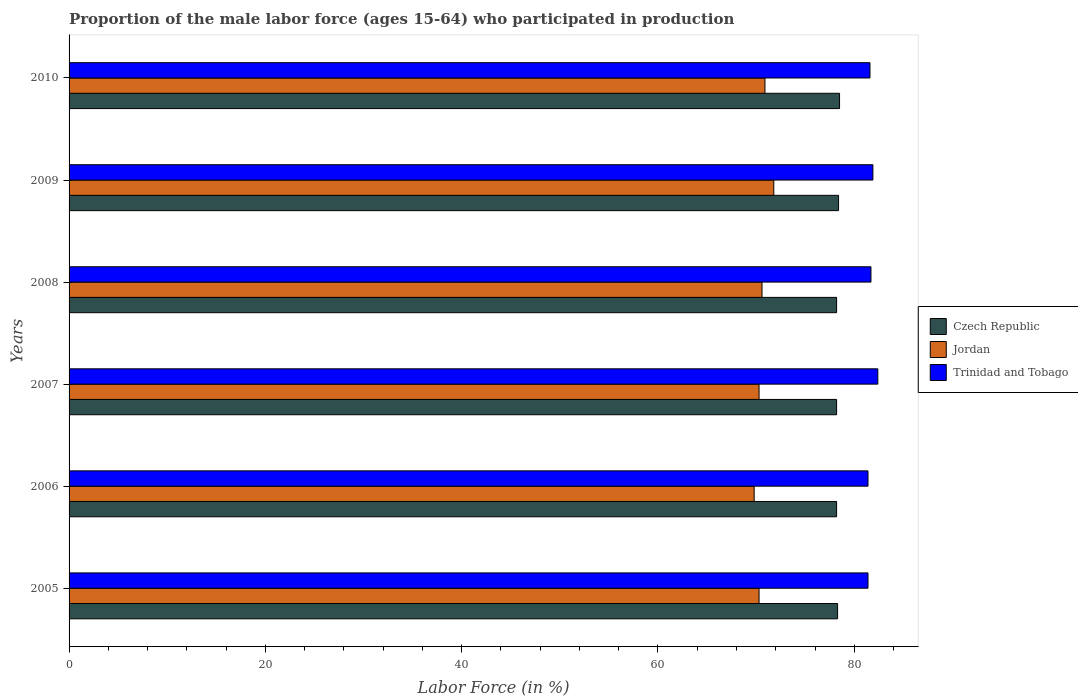How many groups of bars are there?
Ensure brevity in your answer.  6. How many bars are there on the 6th tick from the bottom?
Offer a terse response. 3. In how many cases, is the number of bars for a given year not equal to the number of legend labels?
Offer a very short reply. 0. What is the proportion of the male labor force who participated in production in Jordan in 2008?
Your answer should be very brief. 70.6. Across all years, what is the maximum proportion of the male labor force who participated in production in Trinidad and Tobago?
Your answer should be compact. 82.4. Across all years, what is the minimum proportion of the male labor force who participated in production in Czech Republic?
Keep it short and to the point. 78.2. In which year was the proportion of the male labor force who participated in production in Trinidad and Tobago minimum?
Offer a very short reply. 2005. What is the total proportion of the male labor force who participated in production in Trinidad and Tobago in the graph?
Provide a short and direct response. 490.4. What is the difference between the proportion of the male labor force who participated in production in Czech Republic in 2005 and that in 2010?
Your response must be concise. -0.2. What is the difference between the proportion of the male labor force who participated in production in Trinidad and Tobago in 2006 and the proportion of the male labor force who participated in production in Czech Republic in 2009?
Give a very brief answer. 3. What is the average proportion of the male labor force who participated in production in Trinidad and Tobago per year?
Provide a succinct answer. 81.73. In the year 2010, what is the difference between the proportion of the male labor force who participated in production in Trinidad and Tobago and proportion of the male labor force who participated in production in Czech Republic?
Make the answer very short. 3.1. In how many years, is the proportion of the male labor force who participated in production in Jordan greater than 68 %?
Your response must be concise. 6. What is the ratio of the proportion of the male labor force who participated in production in Jordan in 2005 to that in 2010?
Keep it short and to the point. 0.99. Is the proportion of the male labor force who participated in production in Trinidad and Tobago in 2008 less than that in 2009?
Offer a terse response. Yes. What is the difference between the highest and the second highest proportion of the male labor force who participated in production in Jordan?
Ensure brevity in your answer.  0.9. In how many years, is the proportion of the male labor force who participated in production in Jordan greater than the average proportion of the male labor force who participated in production in Jordan taken over all years?
Your answer should be very brief. 2. Is the sum of the proportion of the male labor force who participated in production in Czech Republic in 2009 and 2010 greater than the maximum proportion of the male labor force who participated in production in Trinidad and Tobago across all years?
Provide a succinct answer. Yes. What does the 3rd bar from the top in 2008 represents?
Offer a very short reply. Czech Republic. What does the 2nd bar from the bottom in 2006 represents?
Your answer should be compact. Jordan. How many years are there in the graph?
Ensure brevity in your answer.  6. Are the values on the major ticks of X-axis written in scientific E-notation?
Ensure brevity in your answer.  No. Does the graph contain any zero values?
Your answer should be very brief. No. Does the graph contain grids?
Your answer should be very brief. No. How many legend labels are there?
Ensure brevity in your answer.  3. What is the title of the graph?
Keep it short and to the point. Proportion of the male labor force (ages 15-64) who participated in production. What is the Labor Force (in %) of Czech Republic in 2005?
Your response must be concise. 78.3. What is the Labor Force (in %) in Jordan in 2005?
Keep it short and to the point. 70.3. What is the Labor Force (in %) in Trinidad and Tobago in 2005?
Make the answer very short. 81.4. What is the Labor Force (in %) in Czech Republic in 2006?
Offer a very short reply. 78.2. What is the Labor Force (in %) of Jordan in 2006?
Give a very brief answer. 69.8. What is the Labor Force (in %) in Trinidad and Tobago in 2006?
Give a very brief answer. 81.4. What is the Labor Force (in %) of Czech Republic in 2007?
Provide a short and direct response. 78.2. What is the Labor Force (in %) of Jordan in 2007?
Keep it short and to the point. 70.3. What is the Labor Force (in %) of Trinidad and Tobago in 2007?
Offer a terse response. 82.4. What is the Labor Force (in %) in Czech Republic in 2008?
Make the answer very short. 78.2. What is the Labor Force (in %) in Jordan in 2008?
Offer a very short reply. 70.6. What is the Labor Force (in %) in Trinidad and Tobago in 2008?
Give a very brief answer. 81.7. What is the Labor Force (in %) in Czech Republic in 2009?
Your answer should be very brief. 78.4. What is the Labor Force (in %) of Jordan in 2009?
Give a very brief answer. 71.8. What is the Labor Force (in %) in Trinidad and Tobago in 2009?
Keep it short and to the point. 81.9. What is the Labor Force (in %) in Czech Republic in 2010?
Your answer should be compact. 78.5. What is the Labor Force (in %) in Jordan in 2010?
Make the answer very short. 70.9. What is the Labor Force (in %) in Trinidad and Tobago in 2010?
Your answer should be very brief. 81.6. Across all years, what is the maximum Labor Force (in %) of Czech Republic?
Offer a very short reply. 78.5. Across all years, what is the maximum Labor Force (in %) of Jordan?
Your answer should be very brief. 71.8. Across all years, what is the maximum Labor Force (in %) in Trinidad and Tobago?
Your answer should be very brief. 82.4. Across all years, what is the minimum Labor Force (in %) in Czech Republic?
Your response must be concise. 78.2. Across all years, what is the minimum Labor Force (in %) of Jordan?
Make the answer very short. 69.8. Across all years, what is the minimum Labor Force (in %) in Trinidad and Tobago?
Keep it short and to the point. 81.4. What is the total Labor Force (in %) of Czech Republic in the graph?
Keep it short and to the point. 469.8. What is the total Labor Force (in %) of Jordan in the graph?
Provide a succinct answer. 423.7. What is the total Labor Force (in %) in Trinidad and Tobago in the graph?
Offer a very short reply. 490.4. What is the difference between the Labor Force (in %) in Czech Republic in 2005 and that in 2006?
Offer a very short reply. 0.1. What is the difference between the Labor Force (in %) of Jordan in 2005 and that in 2007?
Provide a succinct answer. 0. What is the difference between the Labor Force (in %) in Trinidad and Tobago in 2005 and that in 2007?
Provide a short and direct response. -1. What is the difference between the Labor Force (in %) in Czech Republic in 2005 and that in 2008?
Keep it short and to the point. 0.1. What is the difference between the Labor Force (in %) of Czech Republic in 2005 and that in 2009?
Offer a terse response. -0.1. What is the difference between the Labor Force (in %) in Jordan in 2005 and that in 2009?
Provide a succinct answer. -1.5. What is the difference between the Labor Force (in %) in Trinidad and Tobago in 2005 and that in 2009?
Provide a succinct answer. -0.5. What is the difference between the Labor Force (in %) in Czech Republic in 2005 and that in 2010?
Your response must be concise. -0.2. What is the difference between the Labor Force (in %) in Czech Republic in 2006 and that in 2007?
Provide a short and direct response. 0. What is the difference between the Labor Force (in %) of Jordan in 2006 and that in 2008?
Keep it short and to the point. -0.8. What is the difference between the Labor Force (in %) of Jordan in 2006 and that in 2009?
Provide a short and direct response. -2. What is the difference between the Labor Force (in %) in Trinidad and Tobago in 2006 and that in 2009?
Make the answer very short. -0.5. What is the difference between the Labor Force (in %) of Czech Republic in 2006 and that in 2010?
Provide a succinct answer. -0.3. What is the difference between the Labor Force (in %) in Jordan in 2006 and that in 2010?
Your answer should be compact. -1.1. What is the difference between the Labor Force (in %) of Trinidad and Tobago in 2006 and that in 2010?
Offer a terse response. -0.2. What is the difference between the Labor Force (in %) in Jordan in 2007 and that in 2008?
Ensure brevity in your answer.  -0.3. What is the difference between the Labor Force (in %) in Trinidad and Tobago in 2007 and that in 2009?
Offer a terse response. 0.5. What is the difference between the Labor Force (in %) in Czech Republic in 2009 and that in 2010?
Your response must be concise. -0.1. What is the difference between the Labor Force (in %) of Jordan in 2009 and that in 2010?
Make the answer very short. 0.9. What is the difference between the Labor Force (in %) in Trinidad and Tobago in 2009 and that in 2010?
Make the answer very short. 0.3. What is the difference between the Labor Force (in %) of Czech Republic in 2005 and the Labor Force (in %) of Jordan in 2006?
Make the answer very short. 8.5. What is the difference between the Labor Force (in %) in Czech Republic in 2005 and the Labor Force (in %) in Trinidad and Tobago in 2006?
Make the answer very short. -3.1. What is the difference between the Labor Force (in %) of Jordan in 2005 and the Labor Force (in %) of Trinidad and Tobago in 2006?
Offer a very short reply. -11.1. What is the difference between the Labor Force (in %) of Jordan in 2005 and the Labor Force (in %) of Trinidad and Tobago in 2007?
Your answer should be compact. -12.1. What is the difference between the Labor Force (in %) in Czech Republic in 2005 and the Labor Force (in %) in Jordan in 2008?
Ensure brevity in your answer.  7.7. What is the difference between the Labor Force (in %) in Czech Republic in 2005 and the Labor Force (in %) in Jordan in 2009?
Keep it short and to the point. 6.5. What is the difference between the Labor Force (in %) in Czech Republic in 2006 and the Labor Force (in %) in Jordan in 2007?
Offer a very short reply. 7.9. What is the difference between the Labor Force (in %) in Czech Republic in 2006 and the Labor Force (in %) in Jordan in 2008?
Offer a terse response. 7.6. What is the difference between the Labor Force (in %) of Jordan in 2006 and the Labor Force (in %) of Trinidad and Tobago in 2008?
Ensure brevity in your answer.  -11.9. What is the difference between the Labor Force (in %) in Czech Republic in 2006 and the Labor Force (in %) in Jordan in 2009?
Provide a succinct answer. 6.4. What is the difference between the Labor Force (in %) of Czech Republic in 2006 and the Labor Force (in %) of Trinidad and Tobago in 2009?
Your answer should be compact. -3.7. What is the difference between the Labor Force (in %) of Jordan in 2006 and the Labor Force (in %) of Trinidad and Tobago in 2009?
Your response must be concise. -12.1. What is the difference between the Labor Force (in %) of Czech Republic in 2006 and the Labor Force (in %) of Jordan in 2010?
Offer a very short reply. 7.3. What is the difference between the Labor Force (in %) in Czech Republic in 2006 and the Labor Force (in %) in Trinidad and Tobago in 2010?
Your answer should be compact. -3.4. What is the difference between the Labor Force (in %) of Jordan in 2006 and the Labor Force (in %) of Trinidad and Tobago in 2010?
Your answer should be very brief. -11.8. What is the difference between the Labor Force (in %) in Czech Republic in 2007 and the Labor Force (in %) in Jordan in 2008?
Make the answer very short. 7.6. What is the difference between the Labor Force (in %) in Czech Republic in 2007 and the Labor Force (in %) in Trinidad and Tobago in 2008?
Your answer should be compact. -3.5. What is the difference between the Labor Force (in %) of Jordan in 2007 and the Labor Force (in %) of Trinidad and Tobago in 2008?
Keep it short and to the point. -11.4. What is the difference between the Labor Force (in %) in Czech Republic in 2007 and the Labor Force (in %) in Jordan in 2010?
Your response must be concise. 7.3. What is the difference between the Labor Force (in %) of Jordan in 2007 and the Labor Force (in %) of Trinidad and Tobago in 2010?
Provide a short and direct response. -11.3. What is the difference between the Labor Force (in %) of Czech Republic in 2008 and the Labor Force (in %) of Jordan in 2010?
Keep it short and to the point. 7.3. What is the difference between the Labor Force (in %) of Czech Republic in 2008 and the Labor Force (in %) of Trinidad and Tobago in 2010?
Your response must be concise. -3.4. What is the difference between the Labor Force (in %) of Jordan in 2009 and the Labor Force (in %) of Trinidad and Tobago in 2010?
Make the answer very short. -9.8. What is the average Labor Force (in %) in Czech Republic per year?
Provide a short and direct response. 78.3. What is the average Labor Force (in %) of Jordan per year?
Make the answer very short. 70.62. What is the average Labor Force (in %) in Trinidad and Tobago per year?
Offer a very short reply. 81.73. In the year 2005, what is the difference between the Labor Force (in %) in Czech Republic and Labor Force (in %) in Jordan?
Keep it short and to the point. 8. In the year 2005, what is the difference between the Labor Force (in %) in Czech Republic and Labor Force (in %) in Trinidad and Tobago?
Provide a succinct answer. -3.1. In the year 2006, what is the difference between the Labor Force (in %) in Jordan and Labor Force (in %) in Trinidad and Tobago?
Give a very brief answer. -11.6. In the year 2007, what is the difference between the Labor Force (in %) in Czech Republic and Labor Force (in %) in Jordan?
Provide a succinct answer. 7.9. In the year 2007, what is the difference between the Labor Force (in %) in Czech Republic and Labor Force (in %) in Trinidad and Tobago?
Provide a succinct answer. -4.2. In the year 2008, what is the difference between the Labor Force (in %) in Czech Republic and Labor Force (in %) in Trinidad and Tobago?
Your response must be concise. -3.5. In the year 2009, what is the difference between the Labor Force (in %) in Jordan and Labor Force (in %) in Trinidad and Tobago?
Provide a short and direct response. -10.1. What is the ratio of the Labor Force (in %) in Jordan in 2005 to that in 2006?
Your response must be concise. 1.01. What is the ratio of the Labor Force (in %) of Trinidad and Tobago in 2005 to that in 2006?
Your response must be concise. 1. What is the ratio of the Labor Force (in %) of Trinidad and Tobago in 2005 to that in 2007?
Provide a short and direct response. 0.99. What is the ratio of the Labor Force (in %) of Jordan in 2005 to that in 2008?
Offer a terse response. 1. What is the ratio of the Labor Force (in %) of Jordan in 2005 to that in 2009?
Your answer should be compact. 0.98. What is the ratio of the Labor Force (in %) in Czech Republic in 2005 to that in 2010?
Keep it short and to the point. 1. What is the ratio of the Labor Force (in %) of Trinidad and Tobago in 2005 to that in 2010?
Provide a succinct answer. 1. What is the ratio of the Labor Force (in %) of Jordan in 2006 to that in 2007?
Provide a short and direct response. 0.99. What is the ratio of the Labor Force (in %) of Trinidad and Tobago in 2006 to that in 2007?
Your response must be concise. 0.99. What is the ratio of the Labor Force (in %) in Jordan in 2006 to that in 2008?
Keep it short and to the point. 0.99. What is the ratio of the Labor Force (in %) of Jordan in 2006 to that in 2009?
Offer a terse response. 0.97. What is the ratio of the Labor Force (in %) in Jordan in 2006 to that in 2010?
Ensure brevity in your answer.  0.98. What is the ratio of the Labor Force (in %) of Trinidad and Tobago in 2006 to that in 2010?
Offer a terse response. 1. What is the ratio of the Labor Force (in %) of Jordan in 2007 to that in 2008?
Keep it short and to the point. 1. What is the ratio of the Labor Force (in %) in Trinidad and Tobago in 2007 to that in 2008?
Provide a short and direct response. 1.01. What is the ratio of the Labor Force (in %) of Czech Republic in 2007 to that in 2009?
Your answer should be compact. 1. What is the ratio of the Labor Force (in %) of Jordan in 2007 to that in 2009?
Offer a very short reply. 0.98. What is the ratio of the Labor Force (in %) in Trinidad and Tobago in 2007 to that in 2009?
Ensure brevity in your answer.  1.01. What is the ratio of the Labor Force (in %) in Czech Republic in 2007 to that in 2010?
Offer a very short reply. 1. What is the ratio of the Labor Force (in %) of Jordan in 2007 to that in 2010?
Give a very brief answer. 0.99. What is the ratio of the Labor Force (in %) in Trinidad and Tobago in 2007 to that in 2010?
Your response must be concise. 1.01. What is the ratio of the Labor Force (in %) of Jordan in 2008 to that in 2009?
Offer a terse response. 0.98. What is the ratio of the Labor Force (in %) of Czech Republic in 2008 to that in 2010?
Make the answer very short. 1. What is the ratio of the Labor Force (in %) of Trinidad and Tobago in 2008 to that in 2010?
Offer a terse response. 1. What is the ratio of the Labor Force (in %) in Czech Republic in 2009 to that in 2010?
Ensure brevity in your answer.  1. What is the ratio of the Labor Force (in %) in Jordan in 2009 to that in 2010?
Provide a short and direct response. 1.01. What is the difference between the highest and the second highest Labor Force (in %) in Trinidad and Tobago?
Your answer should be compact. 0.5. What is the difference between the highest and the lowest Labor Force (in %) of Czech Republic?
Your answer should be very brief. 0.3. What is the difference between the highest and the lowest Labor Force (in %) in Jordan?
Make the answer very short. 2. What is the difference between the highest and the lowest Labor Force (in %) in Trinidad and Tobago?
Offer a very short reply. 1. 